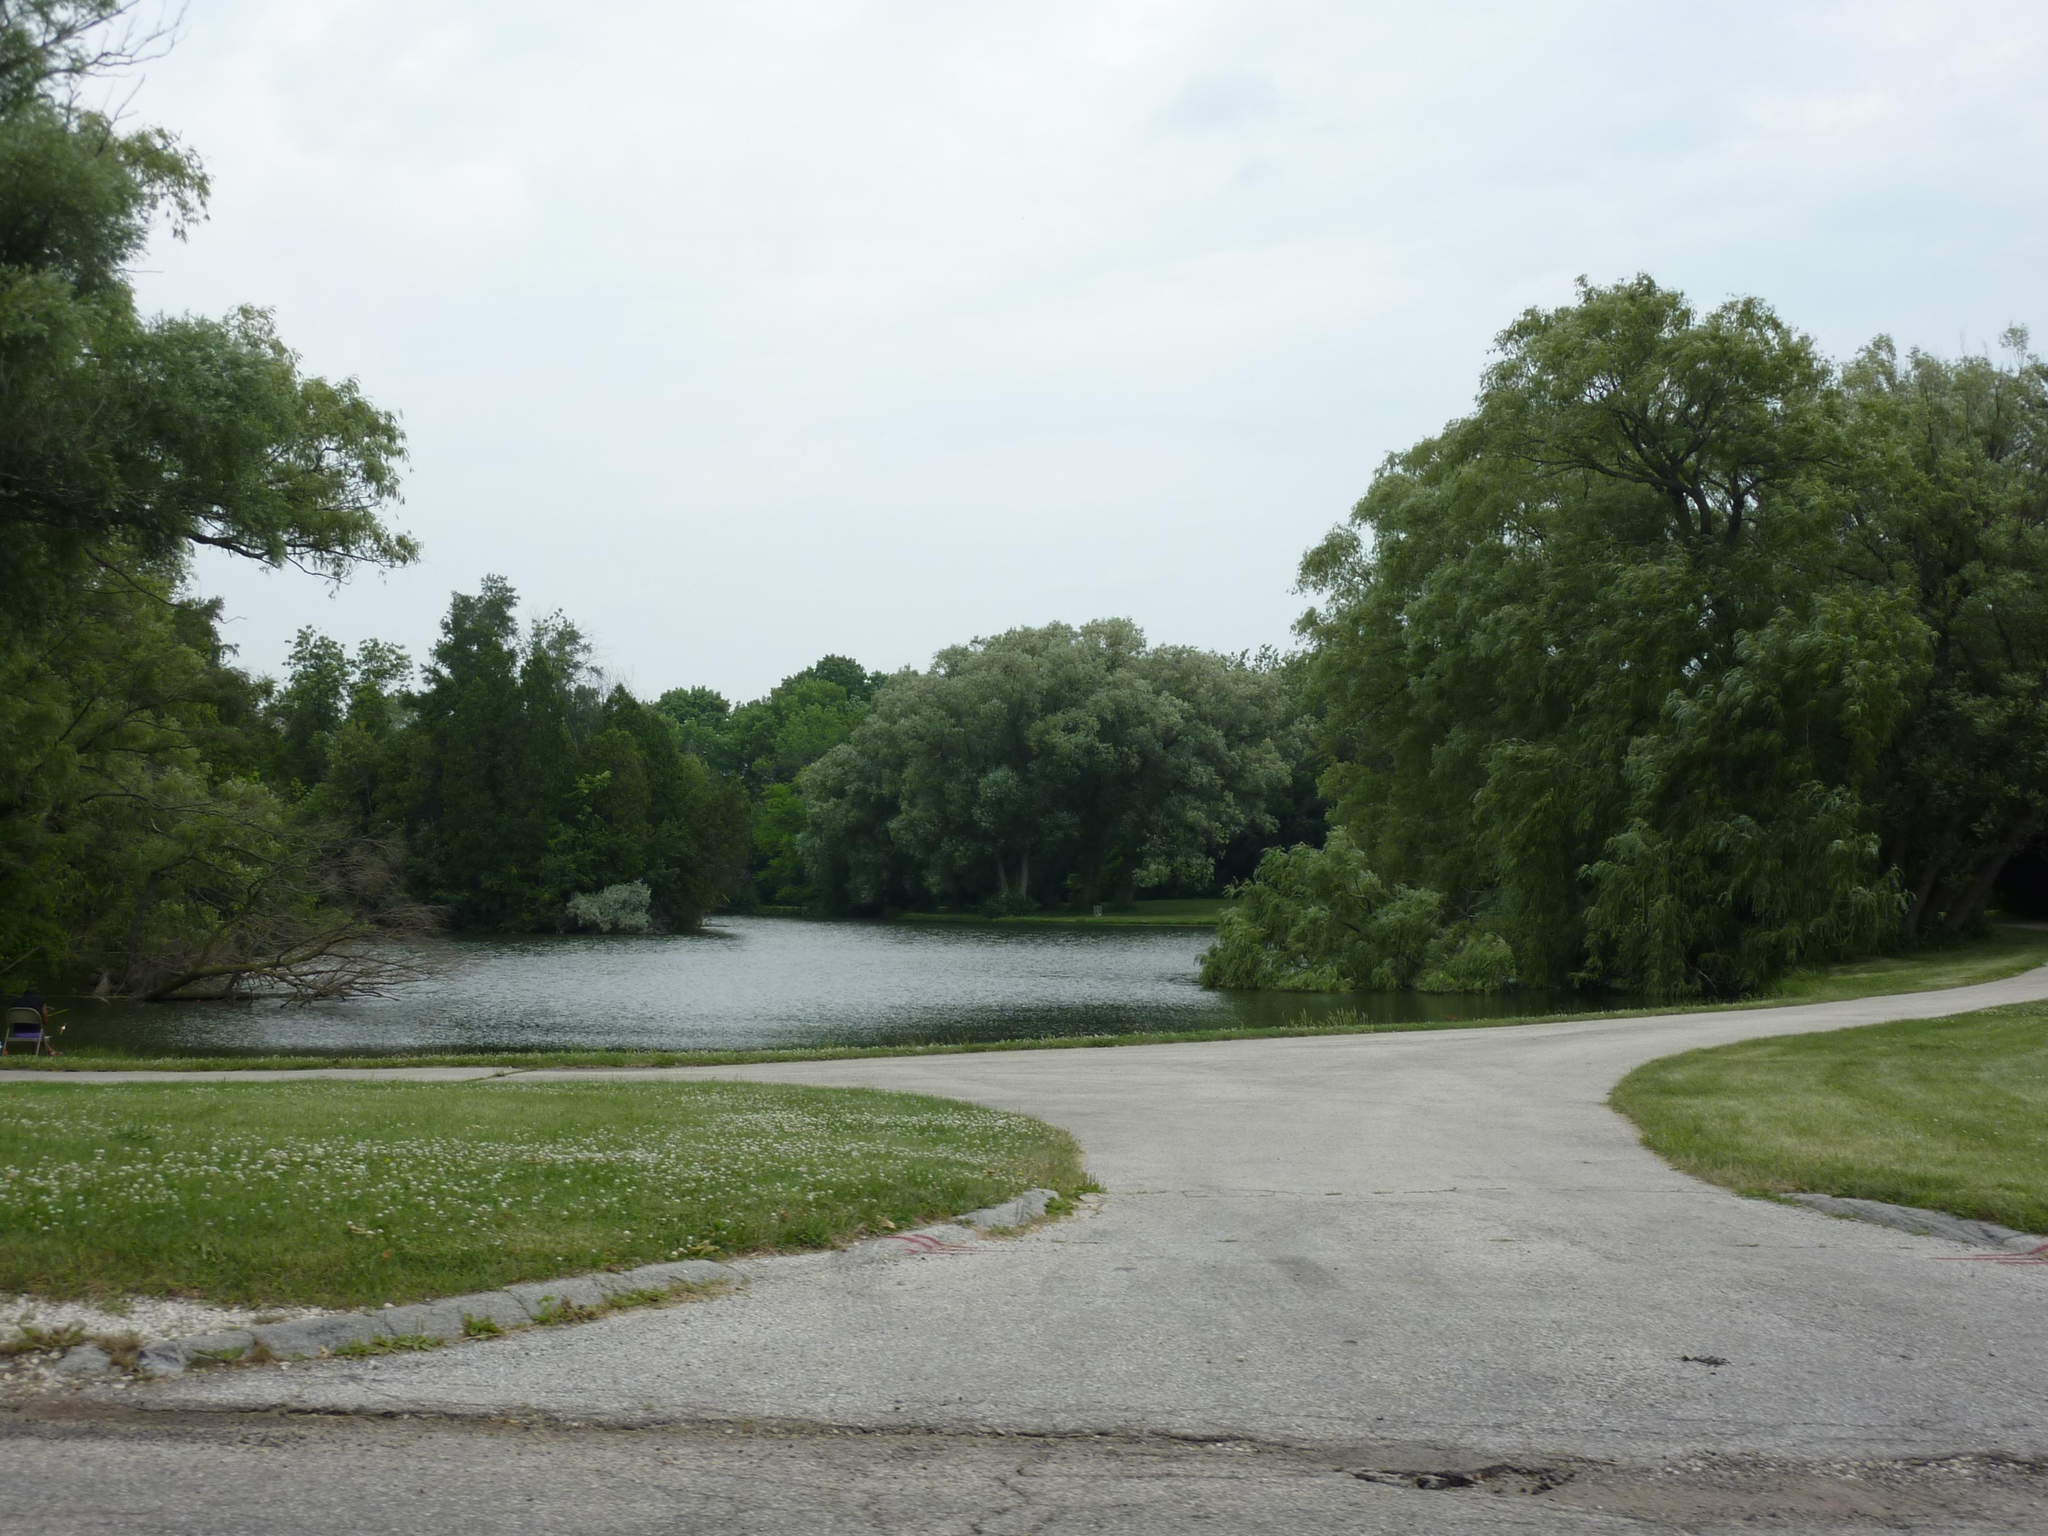What type of natural feature can be seen in the image? There is a water body in the image. What is the man-made feature in the image? There is a pathway in the image. What type of vegetation is present in the image? Grass is present in the image. Where are the trees located in the image? There is a group of trees in the image. How would you describe the sky in the image? The sky is visible in the image, and it appears cloudy. Who is the manager of the vessel in the image? There is no vessel or manager present in the image. 